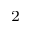Convert formula to latex. <formula><loc_0><loc_0><loc_500><loc_500>^ { 2 }</formula> 